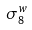Convert formula to latex. <formula><loc_0><loc_0><loc_500><loc_500>\sigma _ { 8 } ^ { w }</formula> 